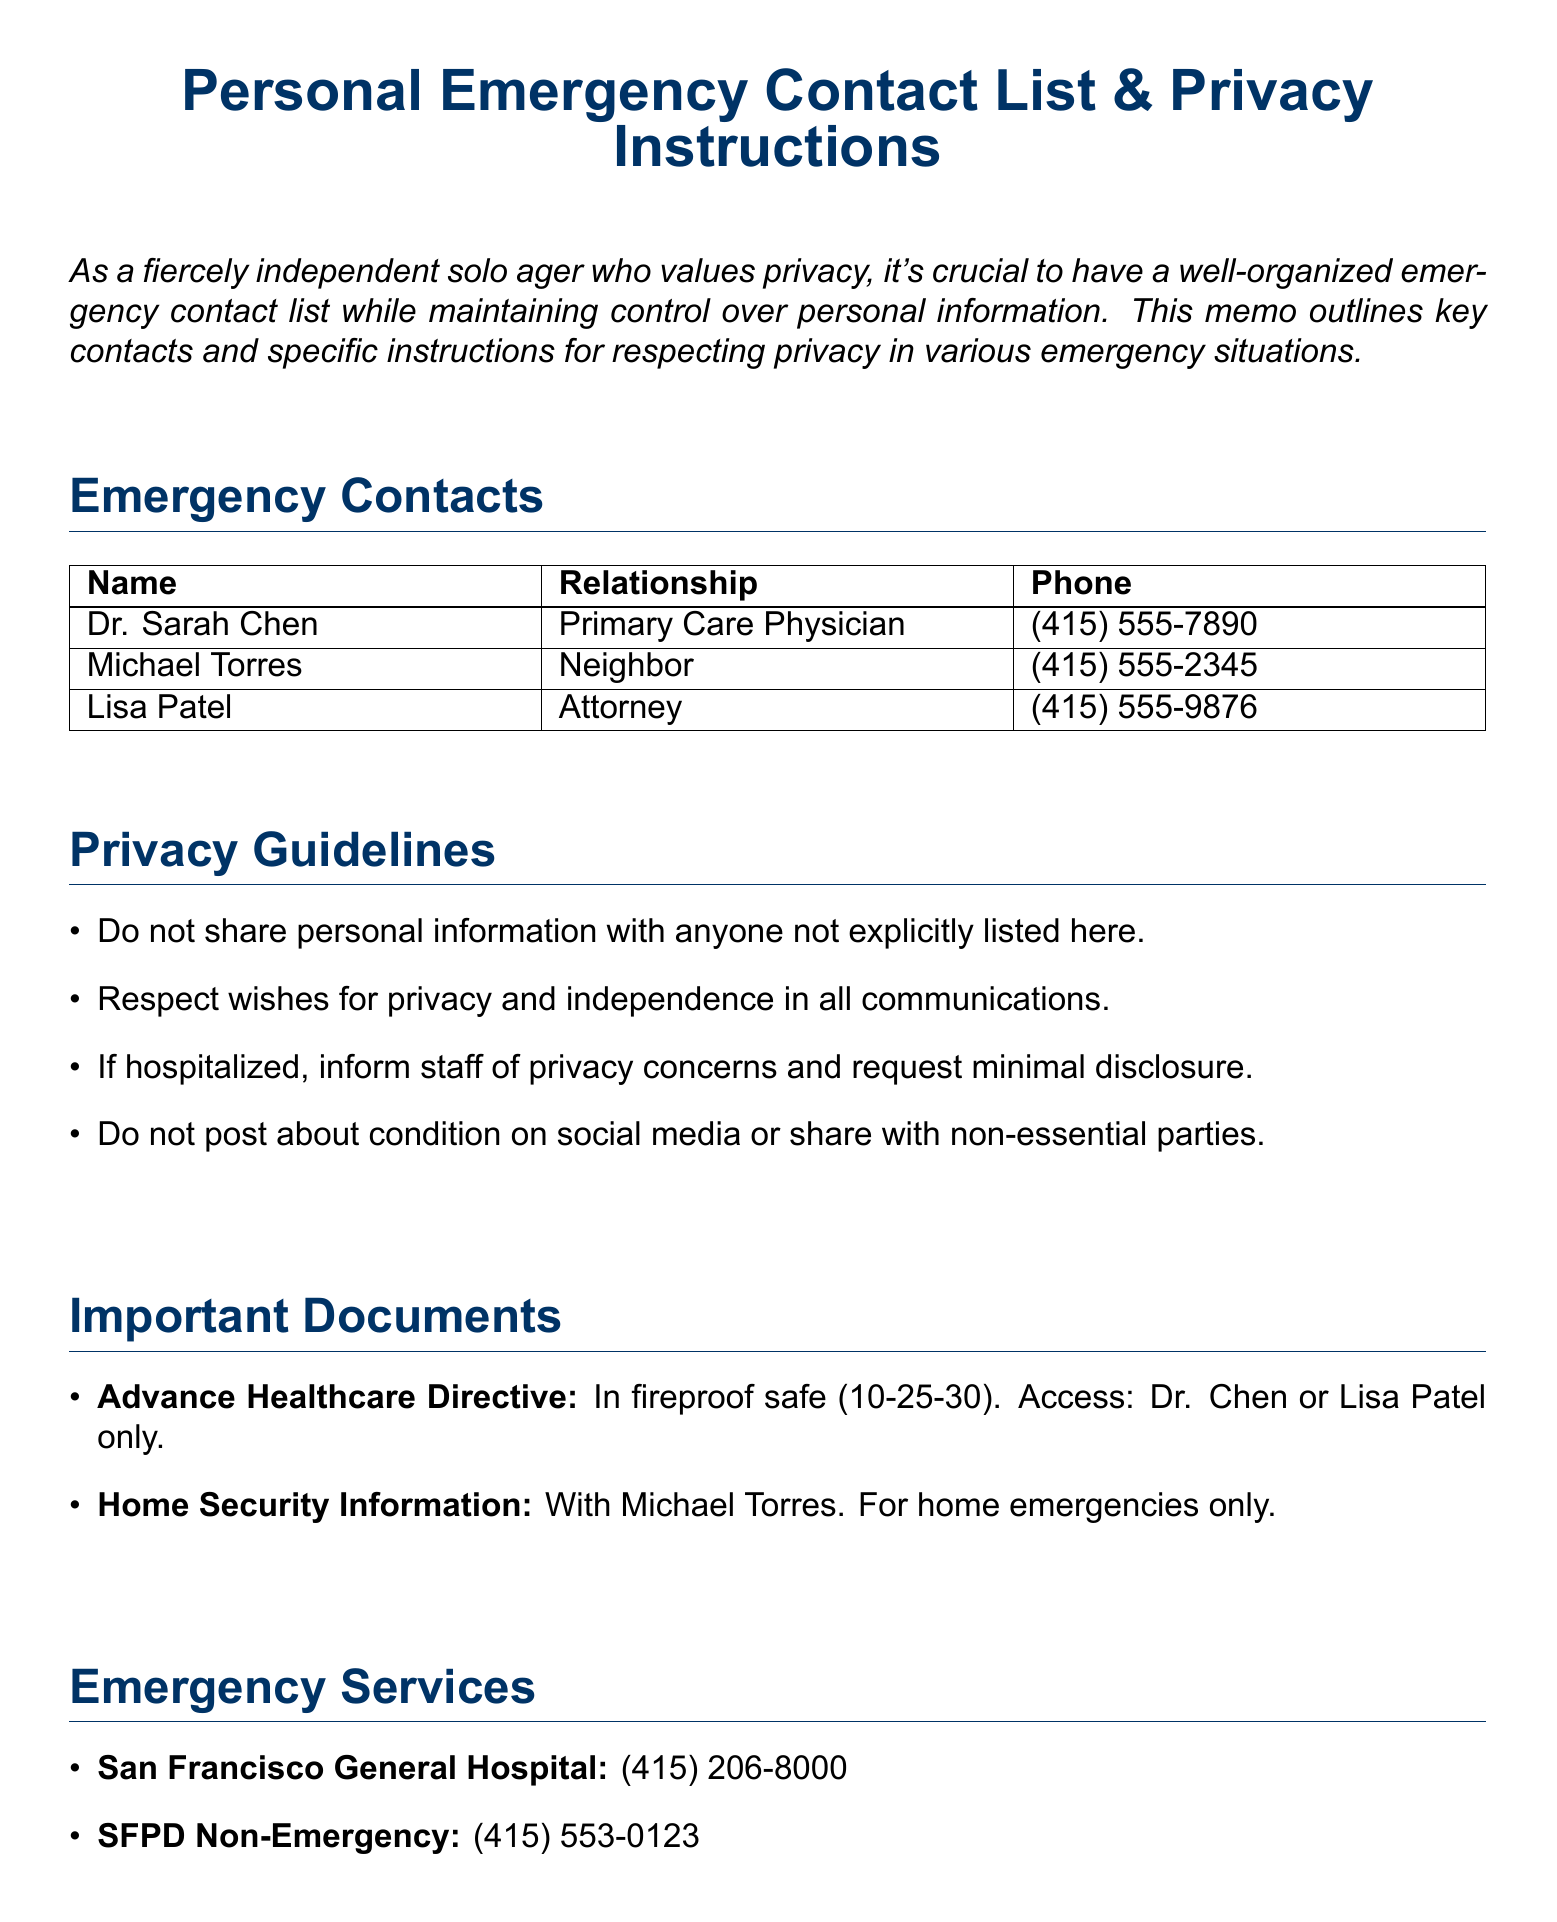What is the name of the primary care physician? The primary care physician listed in the document is Dr. Sarah Chen.
Answer: Dr. Sarah Chen What should be done if hospitalized? The document states to inform staff of privacy concerns and request minimal disclosure of personal details.
Answer: Inform staff of privacy concerns What is the phone number for Michael Torres? Michael Torres's phone number is included in the emergency contacts section, which is (415) 555-2345.
Answer: (415) 555-2345 Who has limited power of attorney? The attorney listed is Lisa Patel, who has limited power of attorney as mentioned in the instructions.
Answer: Lisa Patel Where is the Advance Healthcare Directive located? The document specifies that the Advance Healthcare Directive is in the fireproof safe with the combination 10-25-30.
Answer: In the fireproof safe, combination 10-25-30 What should be requested when admitted to the preferred hospital? The document instructs to inform the hospital of privacy concerns upon admission.
Answer: Inform of privacy concerns For what type of emergencies should Michael Torres be contacted? The instructions specify that Michael Torres should be contacted for home-related emergencies only.
Answer: Home-related emergencies only What is the email privacy measure taken? The document mentions an auto-responder set up for extended absences to maintain privacy in email communications.
Answer: Auto-responder set up 